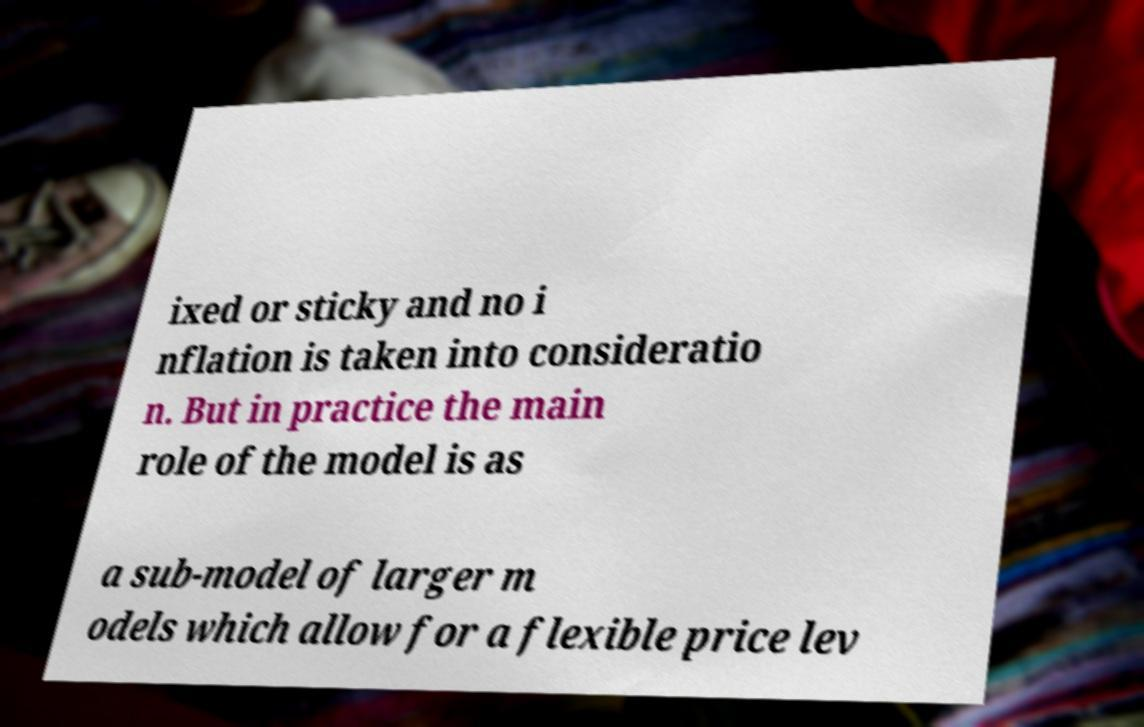For documentation purposes, I need the text within this image transcribed. Could you provide that? ixed or sticky and no i nflation is taken into consideratio n. But in practice the main role of the model is as a sub-model of larger m odels which allow for a flexible price lev 